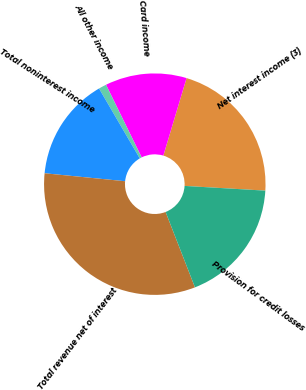Convert chart to OTSL. <chart><loc_0><loc_0><loc_500><loc_500><pie_chart><fcel>Net interest income (3)<fcel>Card income<fcel>All other income<fcel>Total noninterest income<fcel>Total revenue net of interest<fcel>Provision for credit losses<nl><fcel>21.3%<fcel>11.89%<fcel>1.14%<fcel>15.03%<fcel>32.48%<fcel>18.16%<nl></chart> 